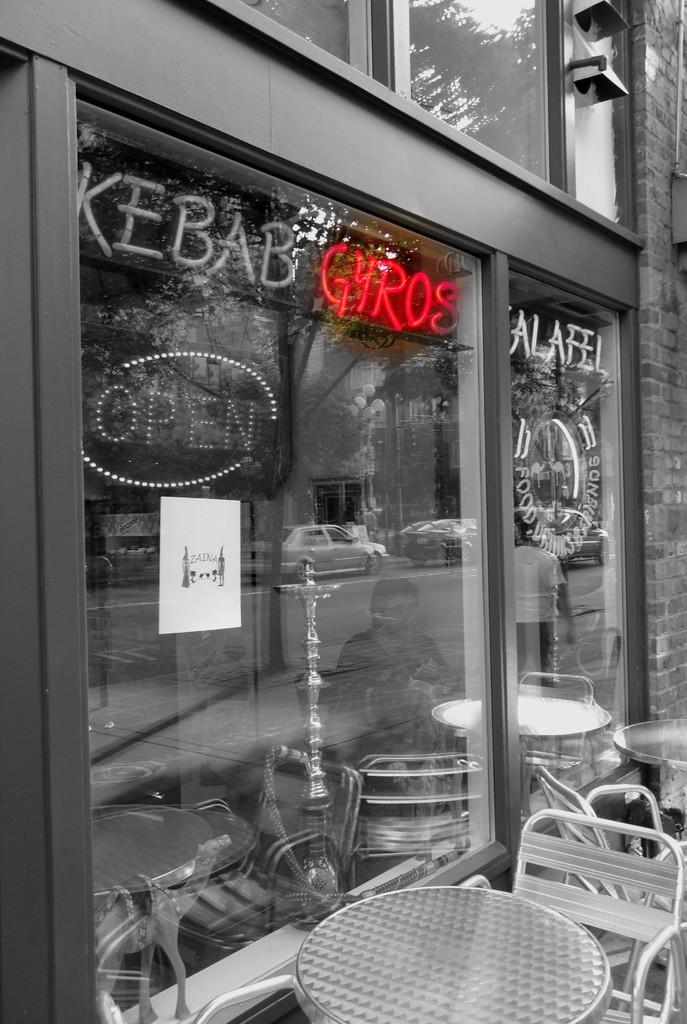Could you give a brief overview of what you see in this image? This looks like an edited image. I think this is a building with the glass doors and the name boards. These are the tables and the chairs. This looks like a poster, which is attached to the glass door. I can see the reflection of the trees and cars. Here is a person standing and a person sitting. 